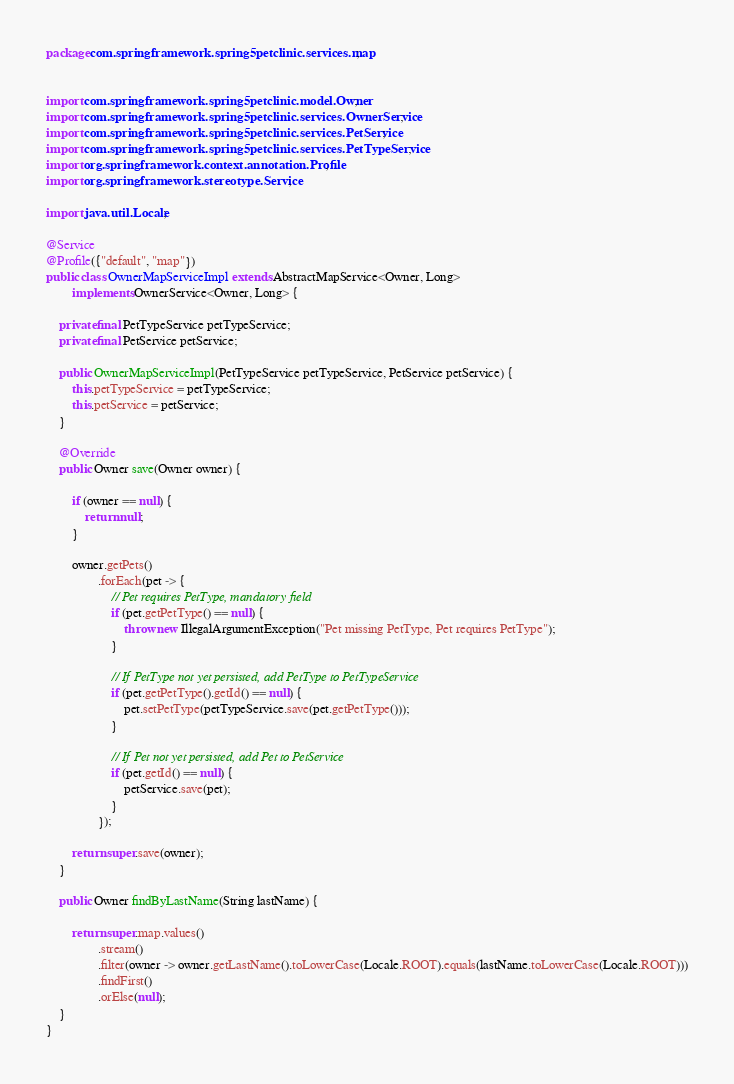Convert code to text. <code><loc_0><loc_0><loc_500><loc_500><_Java_>package com.springframework.spring5petclinic.services.map;


import com.springframework.spring5petclinic.model.Owner;
import com.springframework.spring5petclinic.services.OwnerService;
import com.springframework.spring5petclinic.services.PetService;
import com.springframework.spring5petclinic.services.PetTypeService;
import org.springframework.context.annotation.Profile;
import org.springframework.stereotype.Service;

import java.util.Locale;

@Service
@Profile({"default", "map"})
public class OwnerMapServiceImpl extends AbstractMapService<Owner, Long>
        implements OwnerService<Owner, Long> {

    private final PetTypeService petTypeService;
    private final PetService petService;

    public OwnerMapServiceImpl(PetTypeService petTypeService, PetService petService) {
        this.petTypeService = petTypeService;
        this.petService = petService;
    }

    @Override
    public Owner save(Owner owner) {

        if (owner == null) {
            return null;
        }

        owner.getPets()
                .forEach(pet -> {
                    // Pet requires PetType, mandatory field
                    if (pet.getPetType() == null) {
                        throw new IllegalArgumentException("Pet missing PetType, Pet requires PetType");
                    }

                    // If PetType not yet persisted, add PetType to PetTypeService
                    if (pet.getPetType().getId() == null) {
                        pet.setPetType(petTypeService.save(pet.getPetType()));
                    }

                    // If Pet not yet persisted, add Pet to PetService
                    if (pet.getId() == null) {
                        petService.save(pet);
                    }
                });

        return super.save(owner);
    }

    public Owner findByLastName(String lastName) {

        return super.map.values()
                .stream()
                .filter(owner -> owner.getLastName().toLowerCase(Locale.ROOT).equals(lastName.toLowerCase(Locale.ROOT)))
                .findFirst()
                .orElse(null);
    }
}
</code> 